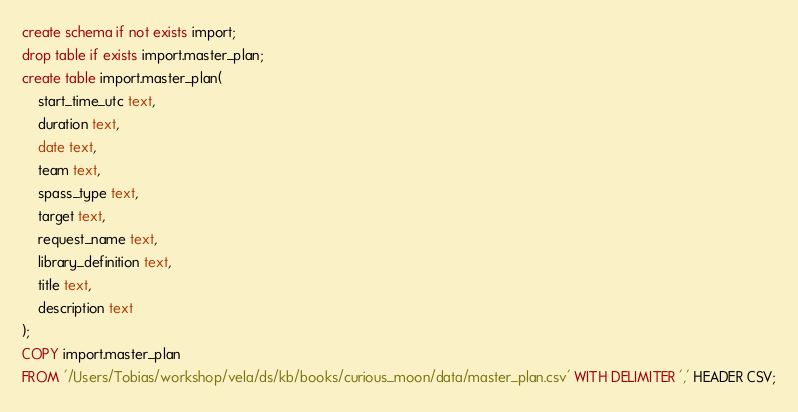<code> <loc_0><loc_0><loc_500><loc_500><_SQL_>create schema if not exists import;
drop table if exists import.master_plan;
create table import.master_plan(
    start_time_utc text,
    duration text,
    date text,
    team text,
    spass_type text,
    target text,
    request_name text,
    library_definition text,
    title text,
    description text
);
COPY import.master_plan
FROM '/Users/Tobias/workshop/vela/ds/kb/books/curious_moon/data/master_plan.csv' WITH DELIMITER ',' HEADER CSV;
</code> 